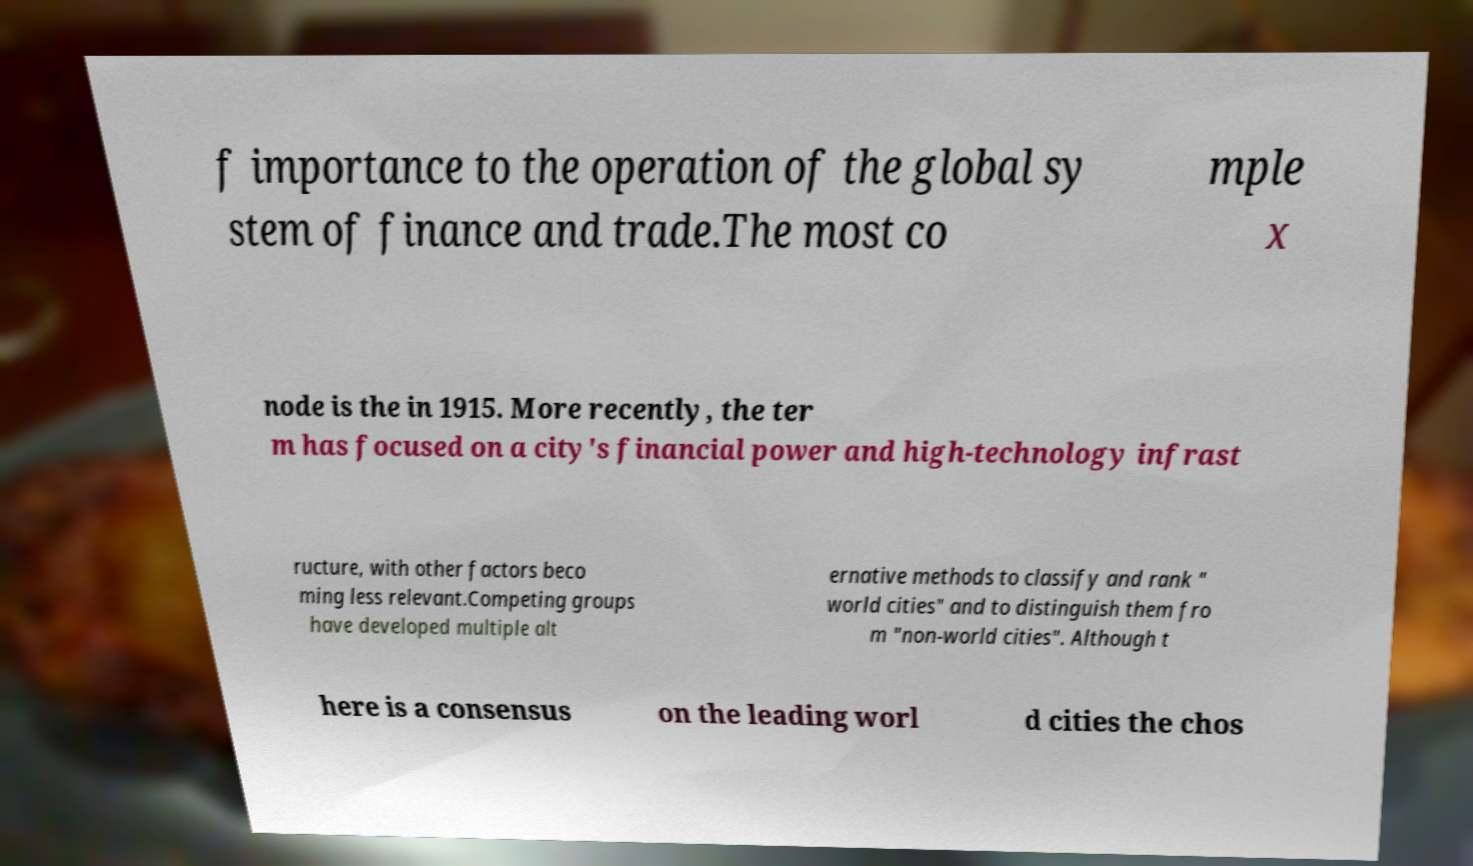There's text embedded in this image that I need extracted. Can you transcribe it verbatim? f importance to the operation of the global sy stem of finance and trade.The most co mple x node is the in 1915. More recently, the ter m has focused on a city's financial power and high-technology infrast ructure, with other factors beco ming less relevant.Competing groups have developed multiple alt ernative methods to classify and rank " world cities" and to distinguish them fro m "non-world cities". Although t here is a consensus on the leading worl d cities the chos 